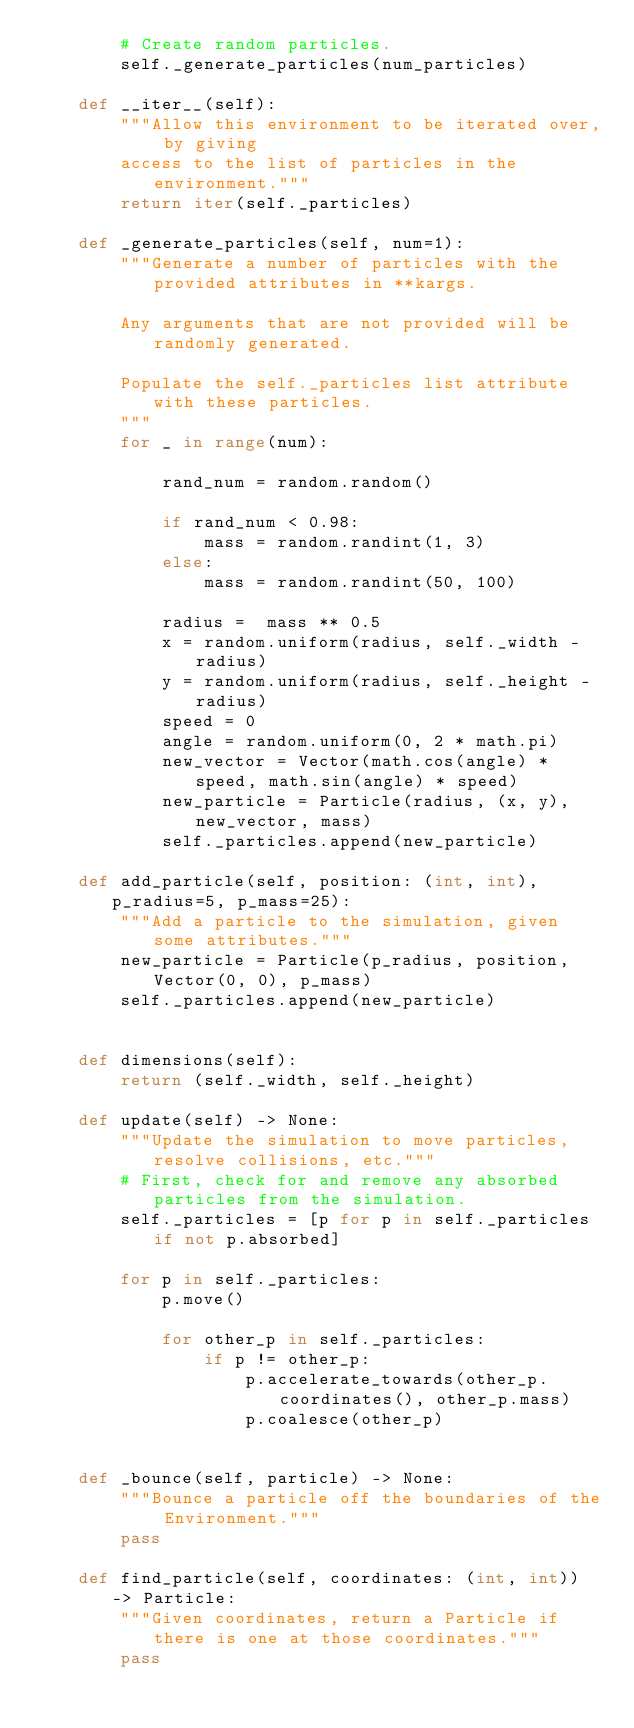<code> <loc_0><loc_0><loc_500><loc_500><_Python_>        # Create random particles.
        self._generate_particles(num_particles)

    def __iter__(self):
        """Allow this environment to be iterated over, by giving
        access to the list of particles in the environment."""
        return iter(self._particles)

    def _generate_particles(self, num=1):
        """Generate a number of particles with the provided attributes in **kargs.

        Any arguments that are not provided will be randomly generated.
        
        Populate the self._particles list attribute with these particles.
        """
        for _ in range(num):

            rand_num = random.random()

            if rand_num < 0.98:
                mass = random.randint(1, 3)
            else:
                mass = random.randint(50, 100)

            radius =  mass ** 0.5
            x = random.uniform(radius, self._width - radius)
            y = random.uniform(radius, self._height - radius)
            speed = 0
            angle = random.uniform(0, 2 * math.pi)
            new_vector = Vector(math.cos(angle) * speed, math.sin(angle) * speed)
            new_particle = Particle(radius, (x, y), new_vector, mass)
            self._particles.append(new_particle)

    def add_particle(self, position: (int, int), p_radius=5, p_mass=25):
        """Add a particle to the simulation, given some attributes."""
        new_particle = Particle(p_radius, position, Vector(0, 0), p_mass)
        self._particles.append(new_particle)
        

    def dimensions(self):
        return (self._width, self._height)

    def update(self) -> None:
        """Update the simulation to move particles, resolve collisions, etc."""
        # First, check for and remove any absorbed particles from the simulation.
        self._particles = [p for p in self._particles if not p.absorbed]

        for p in self._particles:
            p.move()

            for other_p in self._particles:
                if p != other_p:
                    p.accelerate_towards(other_p.coordinates(), other_p.mass)
                    p.coalesce(other_p)
                

    def _bounce(self, particle) -> None:
        """Bounce a particle off the boundaries of the Environment."""
        pass

    def find_particle(self, coordinates: (int, int)) -> Particle:
        """Given coordinates, return a Particle if there is one at those coordinates."""
        pass
</code> 